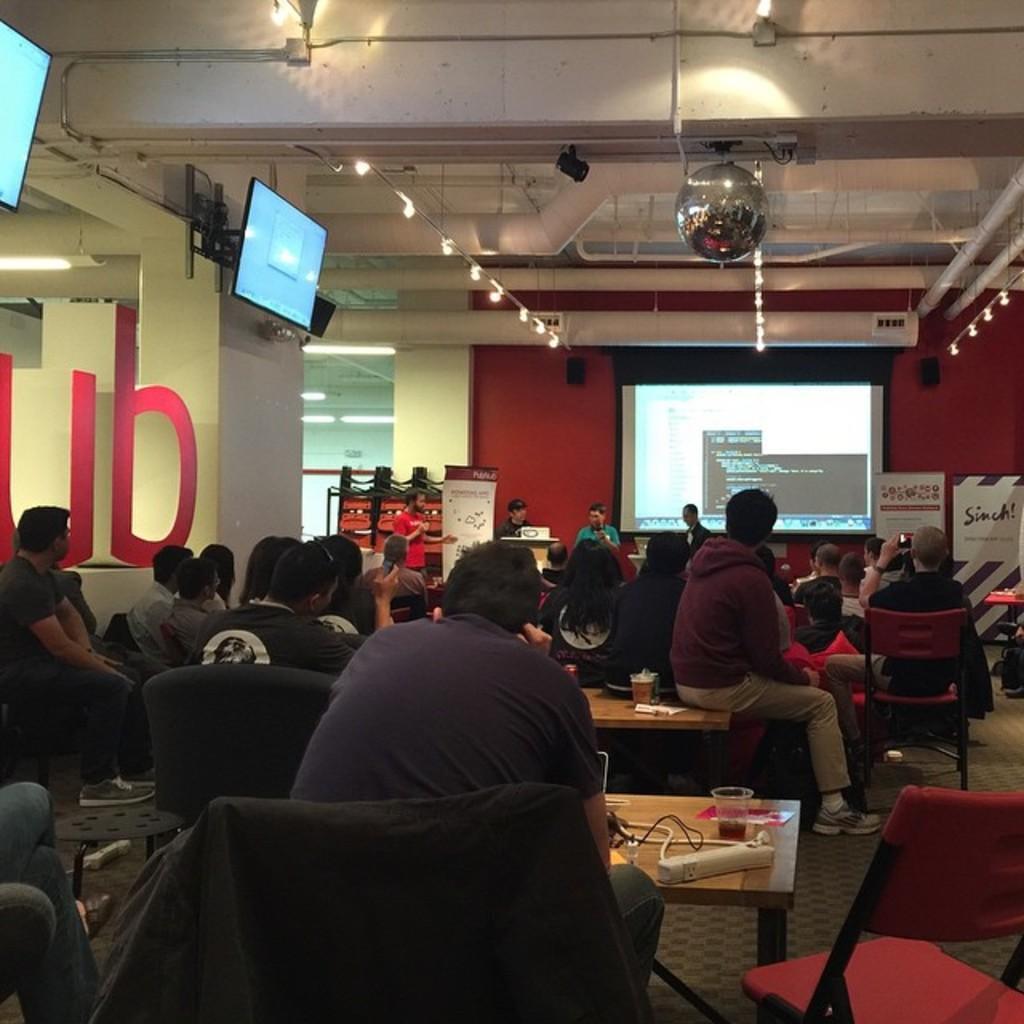Please provide a concise description of this image. This is a conference hall. Many people are sitting on the chair and looking at the screen in front of them. There is person holding a mic beside the screen ,he is talking something. There is pillar on the pillar there is a screen mounted on it. There are table in front of them. There are banners in the background. there are lights attached to the ceiling. 